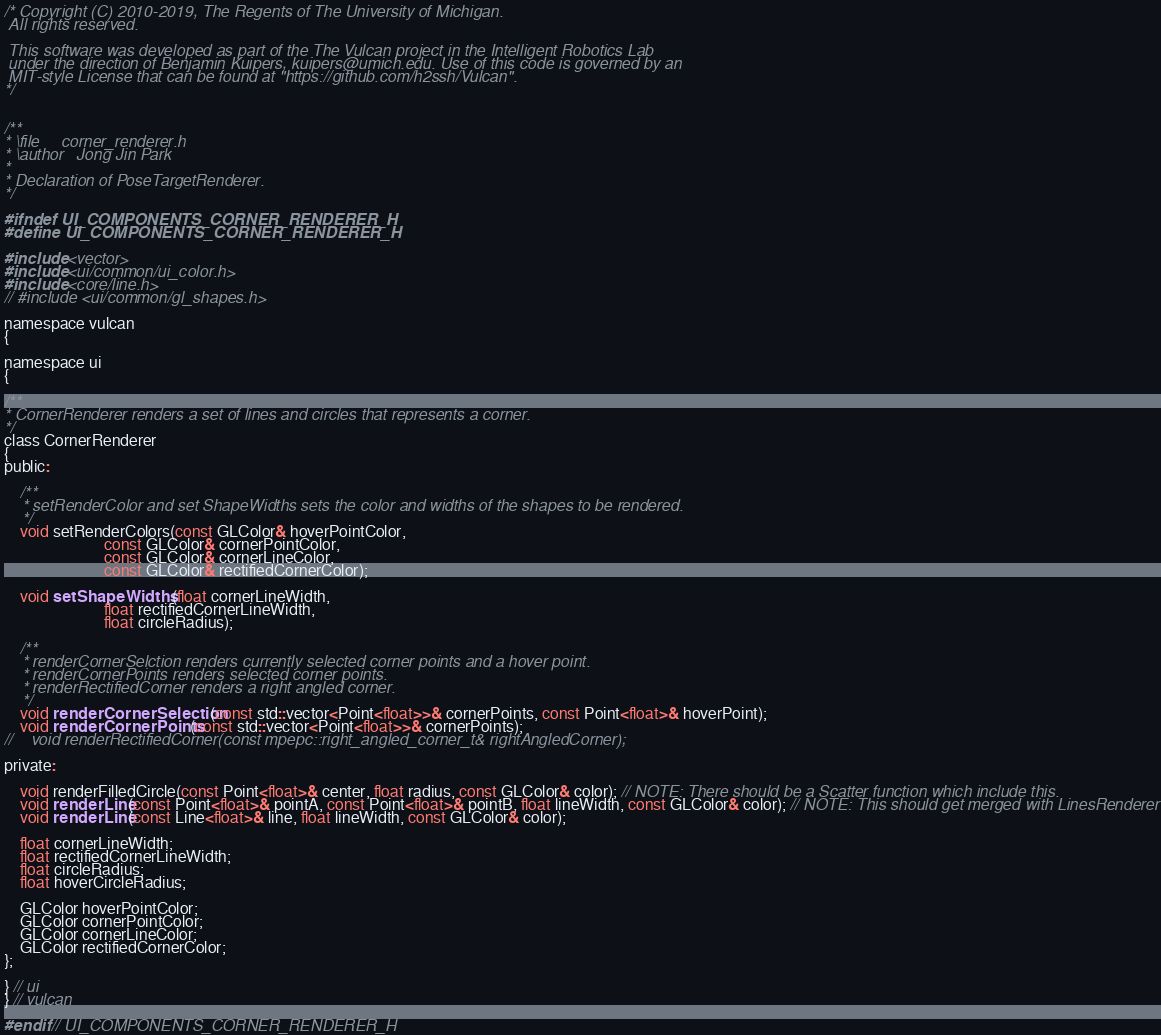<code> <loc_0><loc_0><loc_500><loc_500><_C_>/* Copyright (C) 2010-2019, The Regents of The University of Michigan.
 All rights reserved.

 This software was developed as part of the The Vulcan project in the Intelligent Robotics Lab
 under the direction of Benjamin Kuipers, kuipers@umich.edu. Use of this code is governed by an
 MIT-style License that can be found at "https://github.com/h2ssh/Vulcan".
*/


/**
* \file     corner_renderer.h
* \author   Jong Jin Park
*
* Declaration of PoseTargetRenderer.
*/

#ifndef UI_COMPONENTS_CORNER_RENDERER_H
#define UI_COMPONENTS_CORNER_RENDERER_H

#include <vector>
#include <ui/common/ui_color.h>
#include <core/line.h>
// #include <ui/common/gl_shapes.h>

namespace vulcan
{
    
namespace ui
{

/**
* CornerRenderer renders a set of lines and circles that represents a corner.
*/
class CornerRenderer
{
public:
    
    /**
    * setRenderColor and set ShapeWidths sets the color and widths of the shapes to be rendered.
    */
    void setRenderColors(const GLColor& hoverPointColor,
                         const GLColor& cornerPointColor,
                         const GLColor& cornerLineColor,
                         const GLColor& rectifiedCornerColor);

    void setShapeWidths (float cornerLineWidth,
                         float rectifiedCornerLineWidth,
                         float circleRadius);
    
    /**
    * renderCornerSelction renders currently selected corner points and a hover point.
    * renderCornerPoints renders selected corner points.
    * renderRectifiedCorner renders a right angled corner.
    */
    void renderCornerSelection(const std::vector<Point<float>>& cornerPoints, const Point<float>& hoverPoint);
    void renderCornerPoints(const std::vector<Point<float>>& cornerPoints);
//    void renderRectifiedCorner(const mpepc::right_angled_corner_t& rightAngledCorner);

private:
    
    void renderFilledCircle(const Point<float>& center, float radius, const GLColor& color); // NOTE: There should be a Scatter function which include this.
    void renderLine(const Point<float>& pointA, const Point<float>& pointB, float lineWidth, const GLColor& color); // NOTE: This should get merged with LinesRenderer
    void renderLine(const Line<float>& line, float lineWidth, const GLColor& color);
    
    float cornerLineWidth;
    float rectifiedCornerLineWidth;
    float circleRadius;
    float hoverCircleRadius;
    
    GLColor hoverPointColor;
    GLColor cornerPointColor;
    GLColor cornerLineColor;
    GLColor rectifiedCornerColor;
};

} // ui
} // vulcan

#endif // UI_COMPONENTS_CORNER_RENDERER_H
</code> 